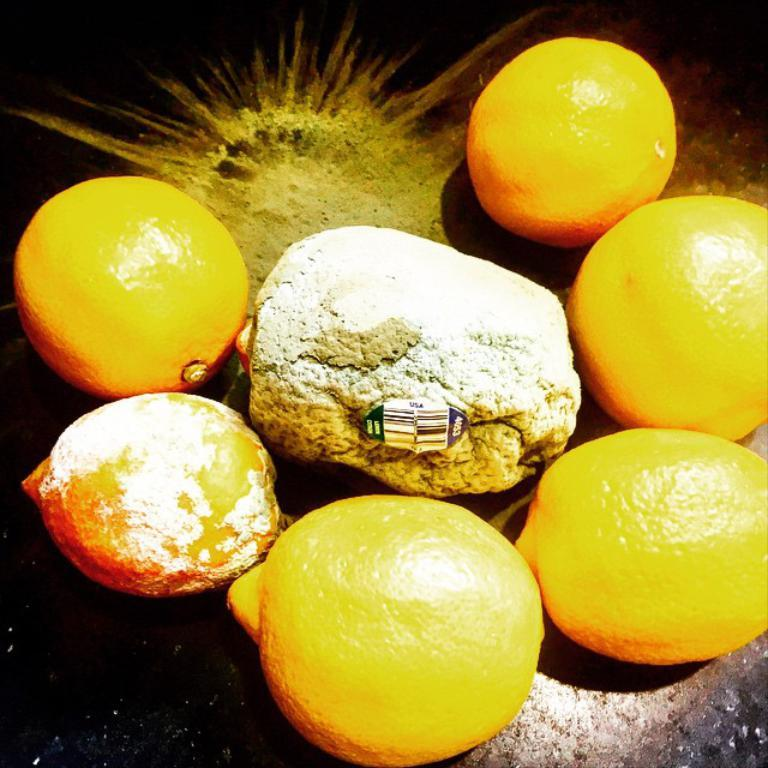What type of food can be seen in the image? There are fruits in the image. Is there any additional detail on the fruits? Yes, there is a sticker on the fruits. What color is the background of the image? The background of the image is black. What type of toy is attacking the fruits in the image? There is no toy present in the image, and the fruits are not being attacked. 